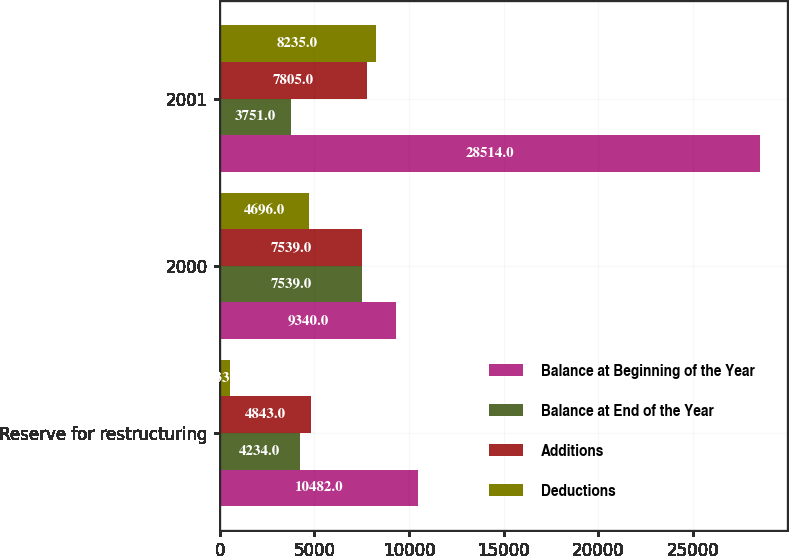Convert chart to OTSL. <chart><loc_0><loc_0><loc_500><loc_500><stacked_bar_chart><ecel><fcel>Reserve for restructuring<fcel>2000<fcel>2001<nl><fcel>Balance at Beginning of the Year<fcel>10482<fcel>9340<fcel>28514<nl><fcel>Balance at End of the Year<fcel>4234<fcel>7539<fcel>3751<nl><fcel>Additions<fcel>4843<fcel>7539<fcel>7805<nl><fcel>Deductions<fcel>533<fcel>4696<fcel>8235<nl></chart> 